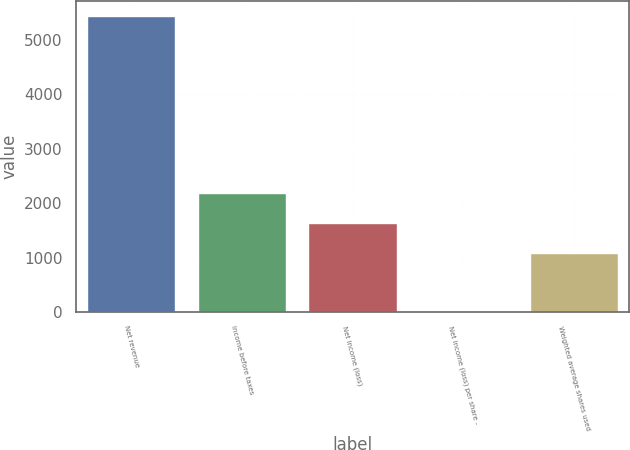Convert chart. <chart><loc_0><loc_0><loc_500><loc_500><bar_chart><fcel>Net revenue<fcel>Income before taxes<fcel>Net income (loss)<fcel>Net income (loss) per share -<fcel>Weighted average shares used<nl><fcel>5444<fcel>2178.77<fcel>1634.57<fcel>1.97<fcel>1090.37<nl></chart> 